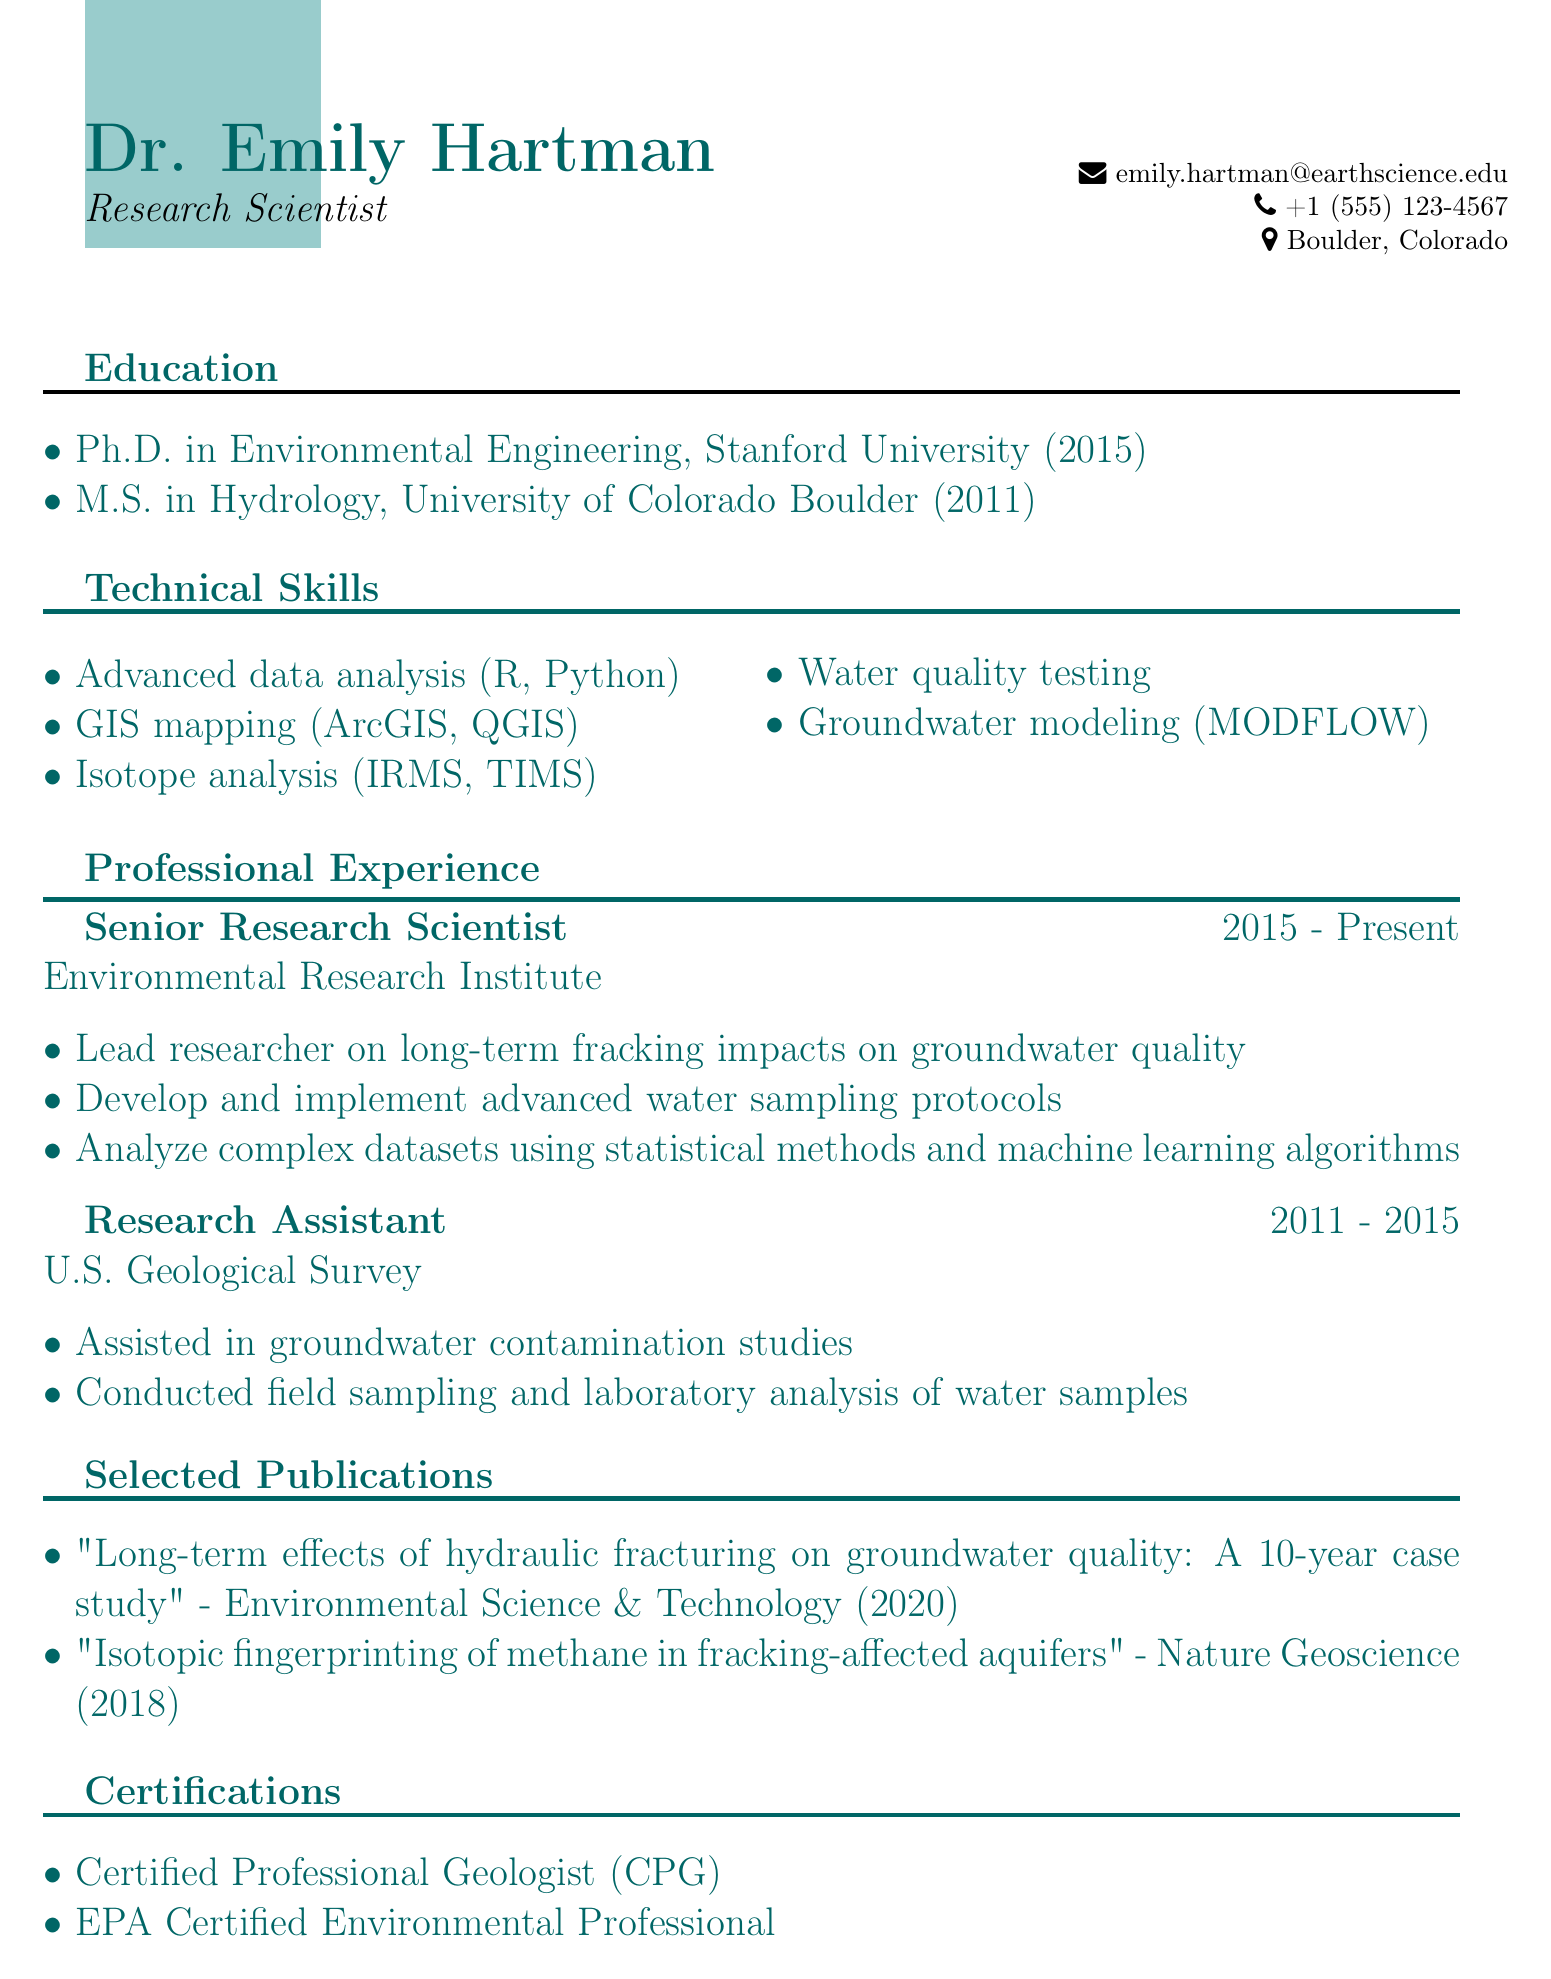What is the name of the research scientist? The document provides the name at the top, which is Dr. Emily Hartman.
Answer: Dr. Emily Hartman What degree did Dr. Emily Hartman obtain in 2015? The document lists Dr. Hartman's degrees, indicating she earned a Ph.D. in Environmental Engineering in 2015.
Answer: Ph.D. in Environmental Engineering Which organization is Dr. Hartman currently associated with? The document states that she is a Senior Research Scientist at the Environmental Research Institute.
Answer: Environmental Research Institute What technique is mentioned for isotope analysis? Under technical skills, the document lists various techniques, including IRMS and TIMS for isotope analysis.
Answer: IRMS, TIMS In what year was the publication about hydraulic fracturing effects released? The document shows the year of this publication as 2020, found in the Selected Publications section.
Answer: 2020 How many years did Dr. Hartman work as a Research Assistant? The professional experience section indicates she held the role from 2011 to 2015, which totals four years.
Answer: 4 years What certifications does Dr. Hartman hold? The document lists her certifications, which include Certified Professional Geologist and EPA Certified Environmental Professional.
Answer: Certified Professional Geologist, EPA Certified Environmental Professional What software is used for GIS mapping? The document specifies ArcGIS and QGIS as software tools for GIS mapping.
Answer: ArcGIS, QGIS 